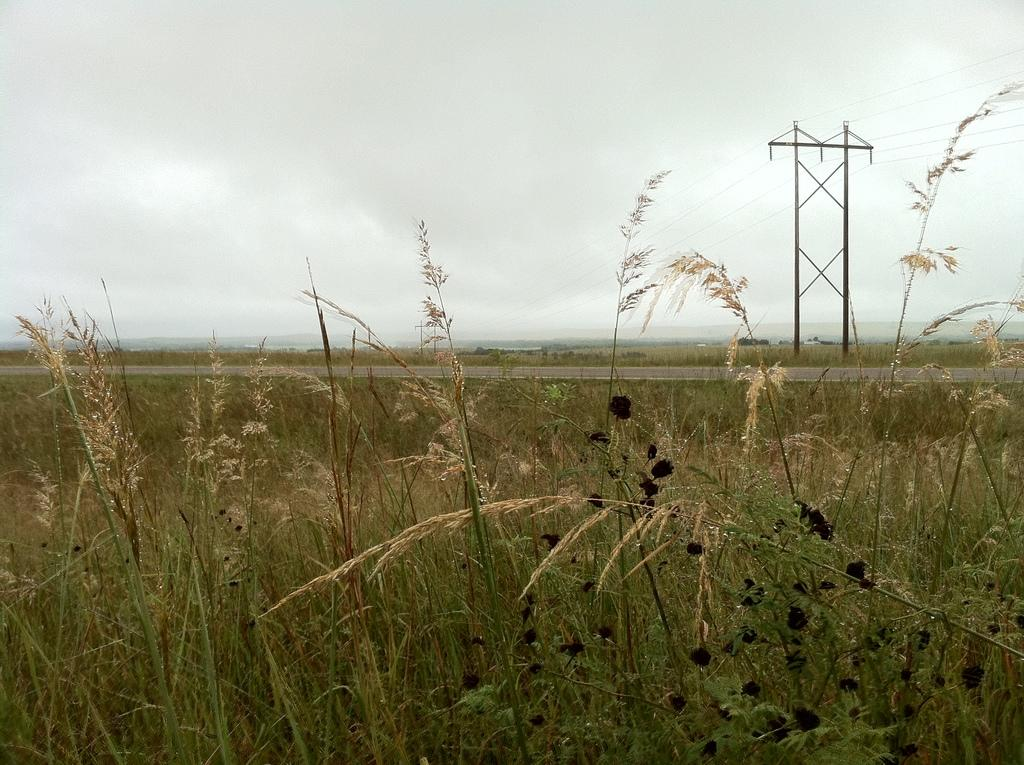What type of living organisms can be seen in the image? Plants can be seen in the image. What can be seen in the background of the image? There are poles and cables in the background of the image. Where is the scarecrow located in the image? There is no scarecrow present in the image. What type of arch can be seen in the image? There is no arch present in the image. 